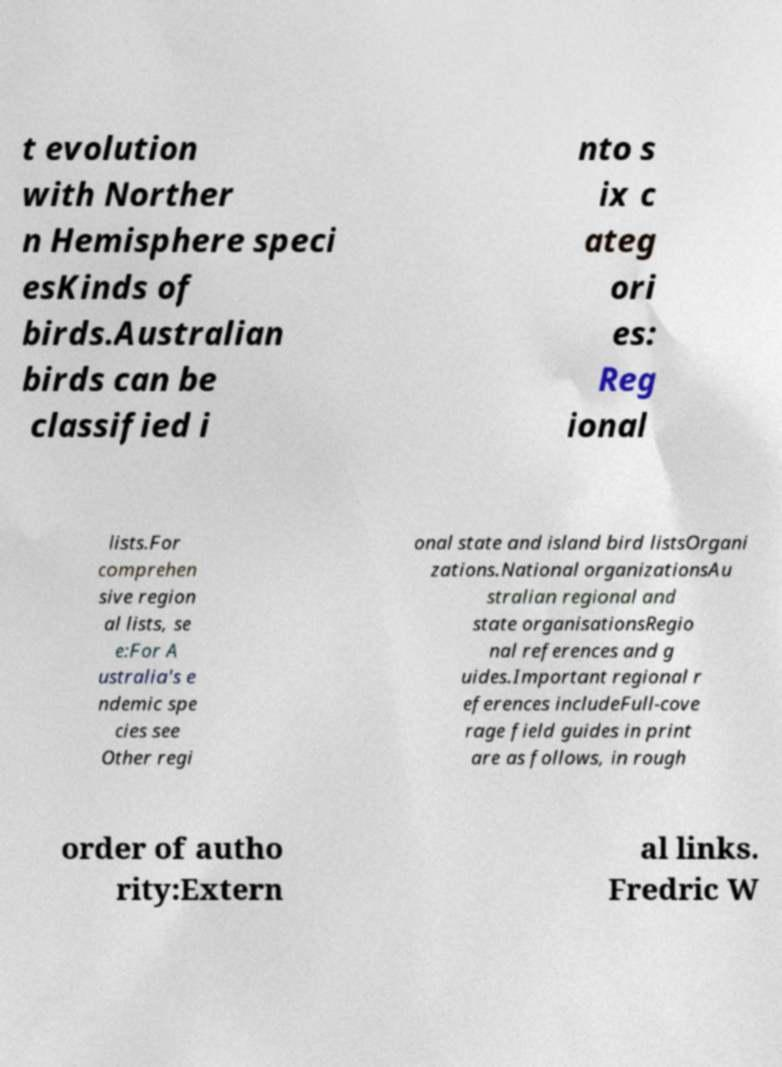Could you extract and type out the text from this image? t evolution with Norther n Hemisphere speci esKinds of birds.Australian birds can be classified i nto s ix c ateg ori es: Reg ional lists.For comprehen sive region al lists, se e:For A ustralia's e ndemic spe cies see Other regi onal state and island bird listsOrgani zations.National organizationsAu stralian regional and state organisationsRegio nal references and g uides.Important regional r eferences includeFull-cove rage field guides in print are as follows, in rough order of autho rity:Extern al links. Fredric W 